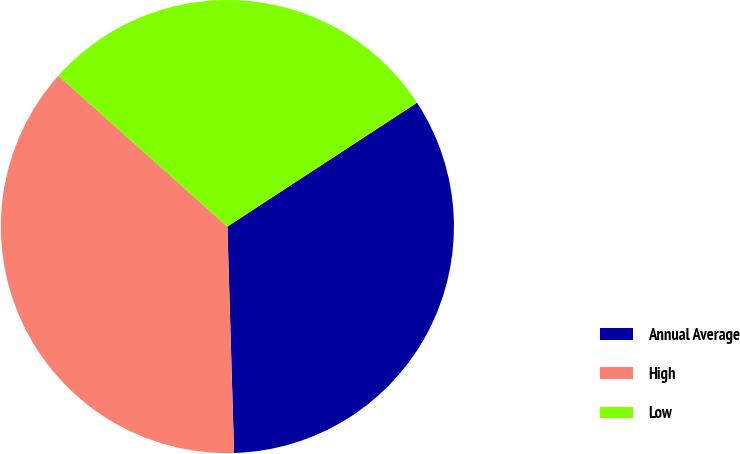Convert chart to OTSL. <chart><loc_0><loc_0><loc_500><loc_500><pie_chart><fcel>Annual Average<fcel>High<fcel>Low<nl><fcel>33.74%<fcel>37.07%<fcel>29.19%<nl></chart> 